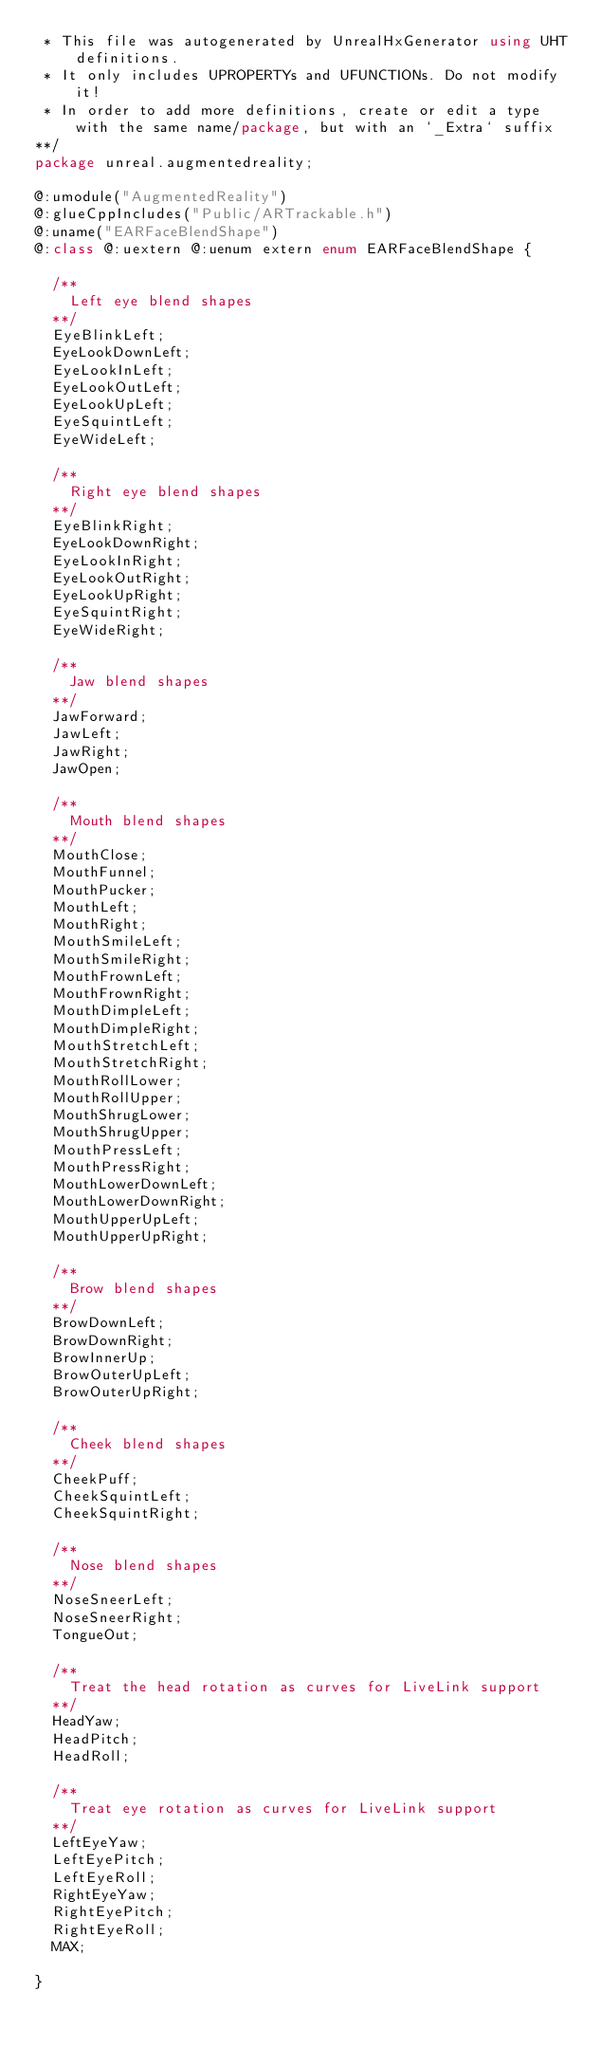<code> <loc_0><loc_0><loc_500><loc_500><_Haxe_> * This file was autogenerated by UnrealHxGenerator using UHT definitions.
 * It only includes UPROPERTYs and UFUNCTIONs. Do not modify it!
 * In order to add more definitions, create or edit a type with the same name/package, but with an `_Extra` suffix
**/
package unreal.augmentedreality;

@:umodule("AugmentedReality")
@:glueCppIncludes("Public/ARTrackable.h")
@:uname("EARFaceBlendShape")
@:class @:uextern @:uenum extern enum EARFaceBlendShape {
  
  /**
    Left eye blend shapes
  **/
  EyeBlinkLeft;
  EyeLookDownLeft;
  EyeLookInLeft;
  EyeLookOutLeft;
  EyeLookUpLeft;
  EyeSquintLeft;
  EyeWideLeft;
  
  /**
    Right eye blend shapes
  **/
  EyeBlinkRight;
  EyeLookDownRight;
  EyeLookInRight;
  EyeLookOutRight;
  EyeLookUpRight;
  EyeSquintRight;
  EyeWideRight;
  
  /**
    Jaw blend shapes
  **/
  JawForward;
  JawLeft;
  JawRight;
  JawOpen;
  
  /**
    Mouth blend shapes
  **/
  MouthClose;
  MouthFunnel;
  MouthPucker;
  MouthLeft;
  MouthRight;
  MouthSmileLeft;
  MouthSmileRight;
  MouthFrownLeft;
  MouthFrownRight;
  MouthDimpleLeft;
  MouthDimpleRight;
  MouthStretchLeft;
  MouthStretchRight;
  MouthRollLower;
  MouthRollUpper;
  MouthShrugLower;
  MouthShrugUpper;
  MouthPressLeft;
  MouthPressRight;
  MouthLowerDownLeft;
  MouthLowerDownRight;
  MouthUpperUpLeft;
  MouthUpperUpRight;
  
  /**
    Brow blend shapes
  **/
  BrowDownLeft;
  BrowDownRight;
  BrowInnerUp;
  BrowOuterUpLeft;
  BrowOuterUpRight;
  
  /**
    Cheek blend shapes
  **/
  CheekPuff;
  CheekSquintLeft;
  CheekSquintRight;
  
  /**
    Nose blend shapes
  **/
  NoseSneerLeft;
  NoseSneerRight;
  TongueOut;
  
  /**
    Treat the head rotation as curves for LiveLink support
  **/
  HeadYaw;
  HeadPitch;
  HeadRoll;
  
  /**
    Treat eye rotation as curves for LiveLink support
  **/
  LeftEyeYaw;
  LeftEyePitch;
  LeftEyeRoll;
  RightEyeYaw;
  RightEyePitch;
  RightEyeRoll;
  MAX;
  
}
</code> 